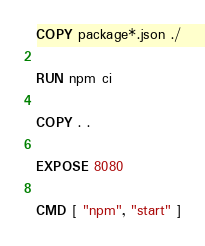Convert code to text. <code><loc_0><loc_0><loc_500><loc_500><_Dockerfile_>
COPY package*.json ./

RUN npm ci

COPY . .

EXPOSE 8080

CMD [ "npm", "start" ]
</code> 